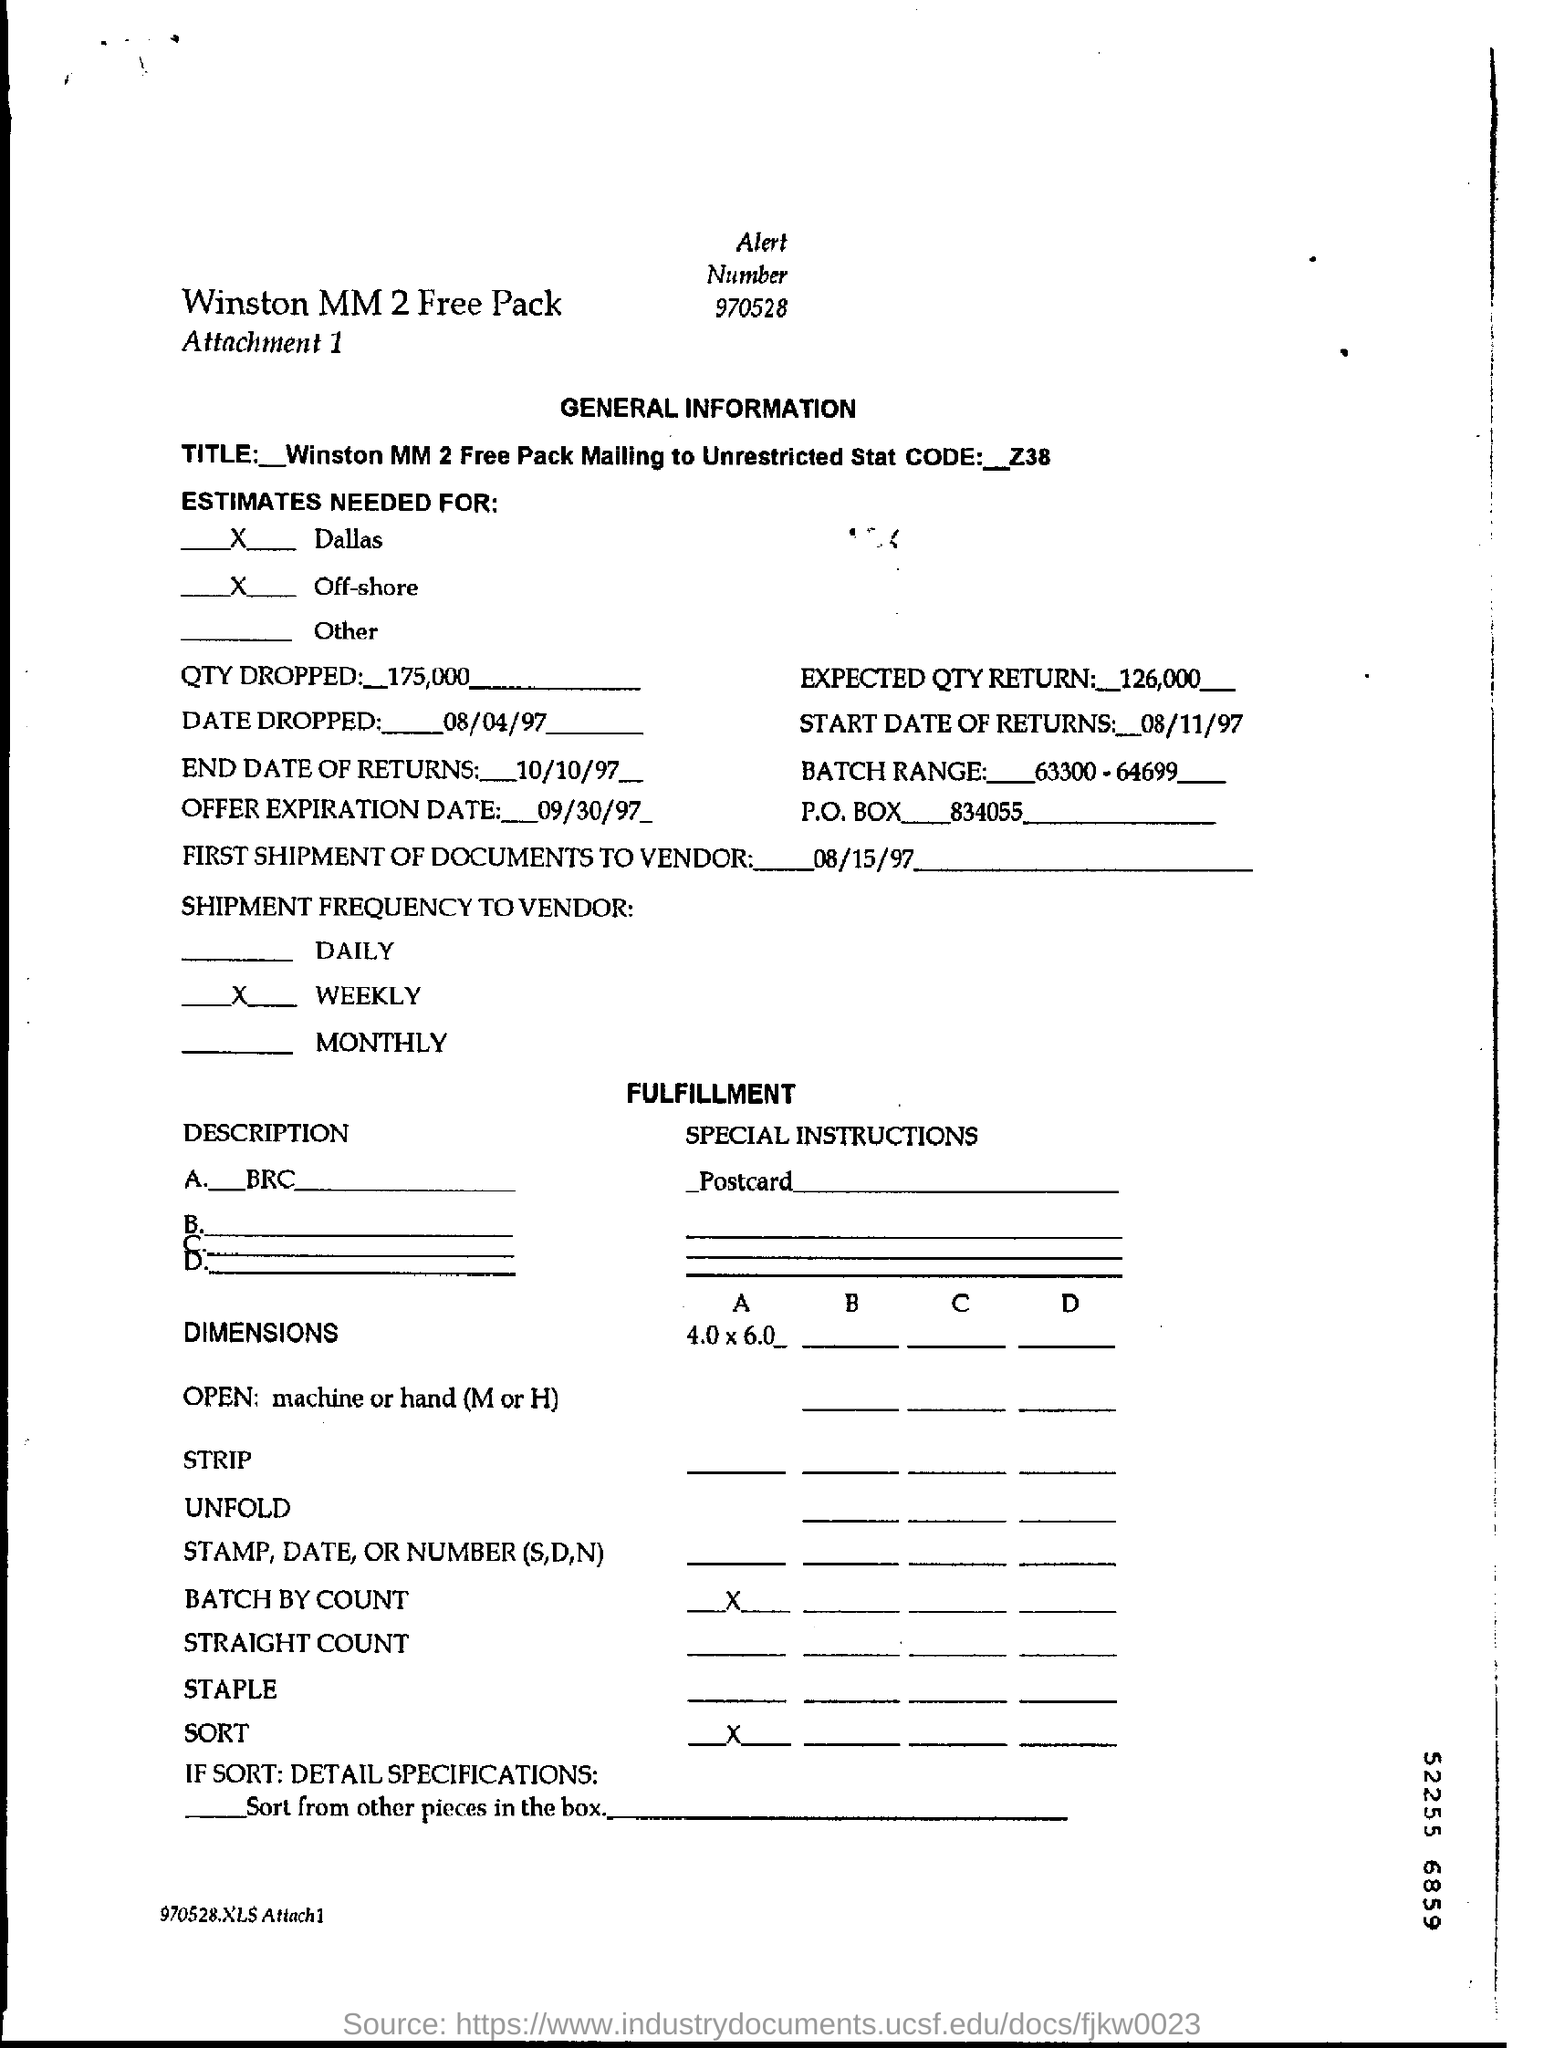Indicate a few pertinent items in this graphic. The Offer Expiration Date is September 30, 1997. The batch range refers to a specific set of numbers, specifically "63300-64699". The end date of returns is October 10, 1997. On August 15, 1997, the first shipment of documents was sent to the vendor. The Expected QTY Return Field contains the value 126,000. 